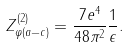Convert formula to latex. <formula><loc_0><loc_0><loc_500><loc_500>Z ^ { ( 2 ) } _ { \varphi ( a - c ) } = \frac { 7 e ^ { 4 } } { 4 8 \pi ^ { 2 } } \frac { 1 } { \epsilon } .</formula> 